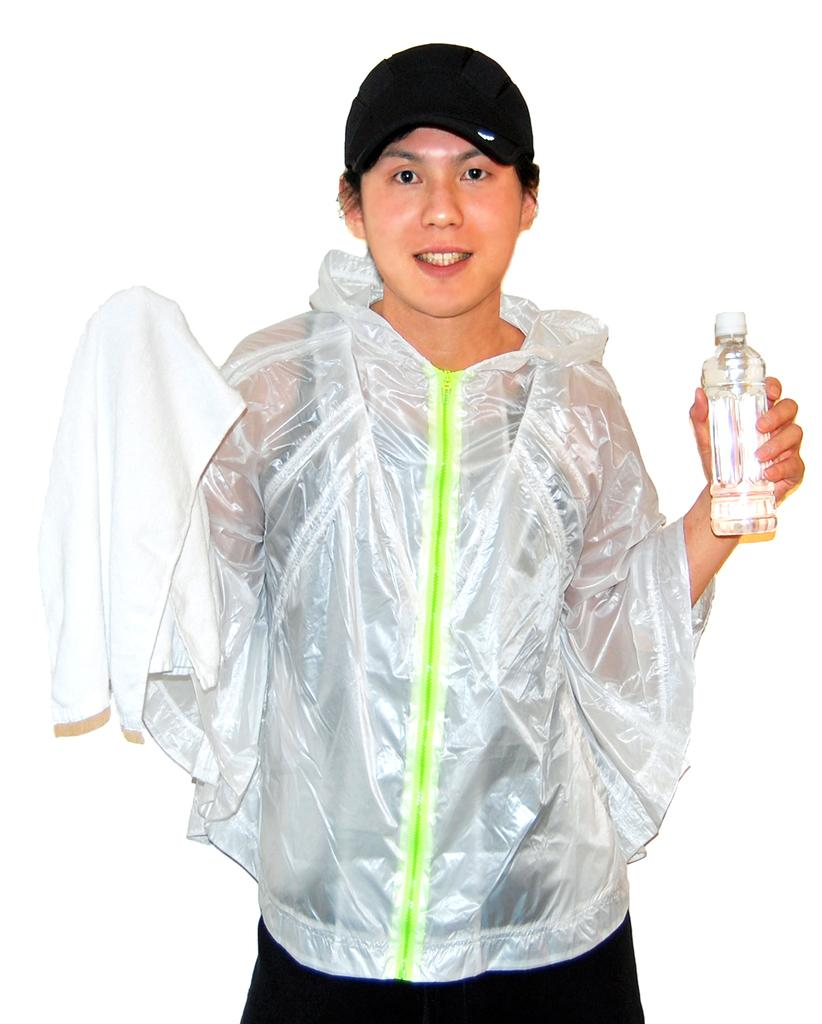What is the main subject of the image? The main subject of the image is a man. What is the man doing in the image? The man is standing in the image. What is the man wearing that is transparent? The man is wearing a transparent coat. What objects is the man holding in the image? The man is holding a bottle and a towel in the image. What type of headwear is the man wearing? The man is wearing a black color cap. How many frogs can be seen jumping around in the image? There are no frogs present in the image. What is the condition of the fire in the image? There is no fire present in the image. 